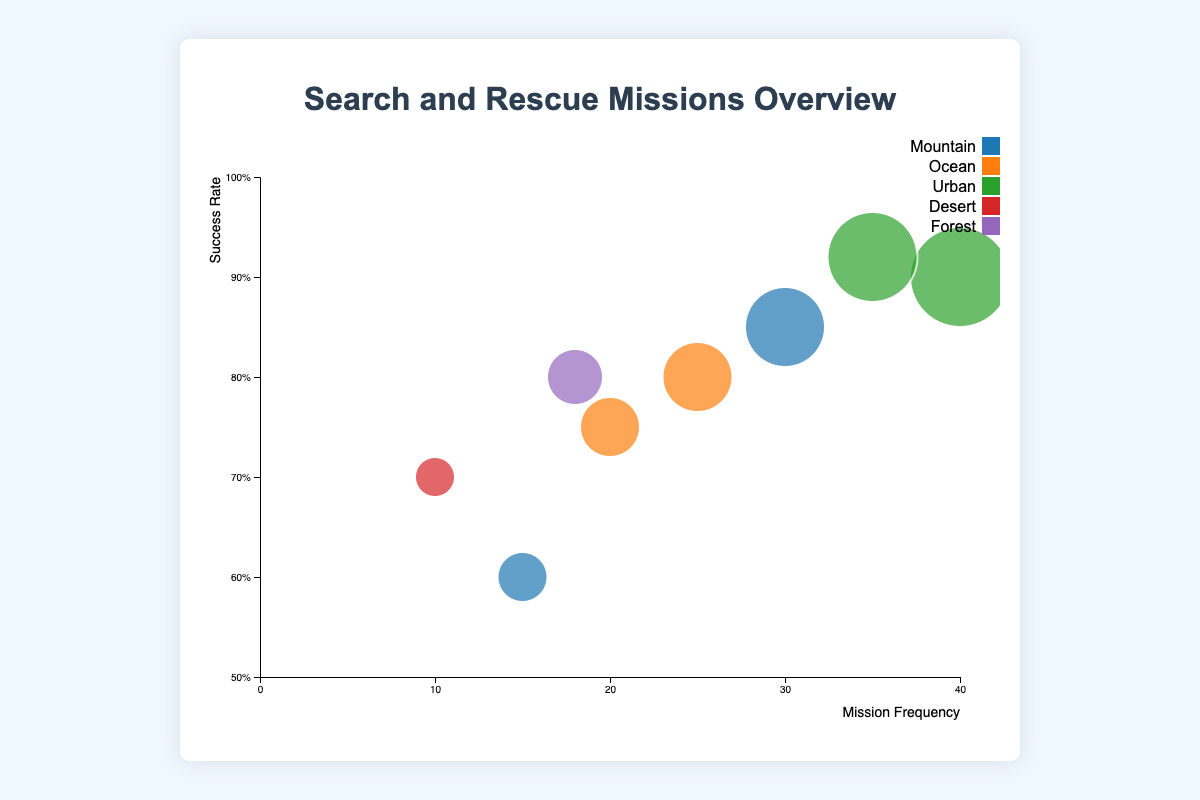What's the title of the chart? The title is visually displayed at the top of the chart container.
Answer: Search and Rescue Missions Overview How many types of missions are represented in the chart? Count the unique mission types presented in the legend section of the chart, which uses color to differentiate them.
Answer: 5 types What is the success rate for urban missions in New York City? Locate the bubble representing New York City, then look at its vertical position on the success rate scale.
Answer: 0.90 or 90% Which mission type has the highest mission frequency? Identify the bubble with the largest size as it represents the highest frequency and refer to the mission type.
Answer: Urban (New York City) What is the combined frequency of Mountain missions in the Rocky Mountains and Himalayas? Add the frequencies of the respective bubbles: 30 (Rocky Mountains) + 15 (Himalayas).
Answer: 45 Compare the success rates: Are missions in the Atlantic Ocean more successful than those in the Pacific Ocean? Check the vertical position of the ocean mission bubbles. Compare the two success rates.
Answer: Yes, Atlantic Ocean (0.80) is more successful than Pacific Ocean (0.75) Which location has the highest success rate for missions? Identify the bubble that is positioned highest vertically on the success rate axis.
Answer: Los Angeles Are missions in urban areas more frequent than those in the ocean? Look at the sizes and the horizontal positioning of the bubbles for urban and ocean mission types.
Answer: Yes, urban missions are more frequent Between the Sahara Desert and the Amazon Rainforest, which location has a higher frequency of search and rescue missions? Compare the sizes of the bubbles for the Sahara Desert and the Amazon Rainforest.
Answer: Amazon Rainforest Is there any mission type that appears to be less frequent than others but has a relatively high success rate? Identify a smaller bubble (less frequent) that is still positioned high on the success rate axis.
Answer: Sahara Desert (Frequency: 10, Success Rate: 0.70) 